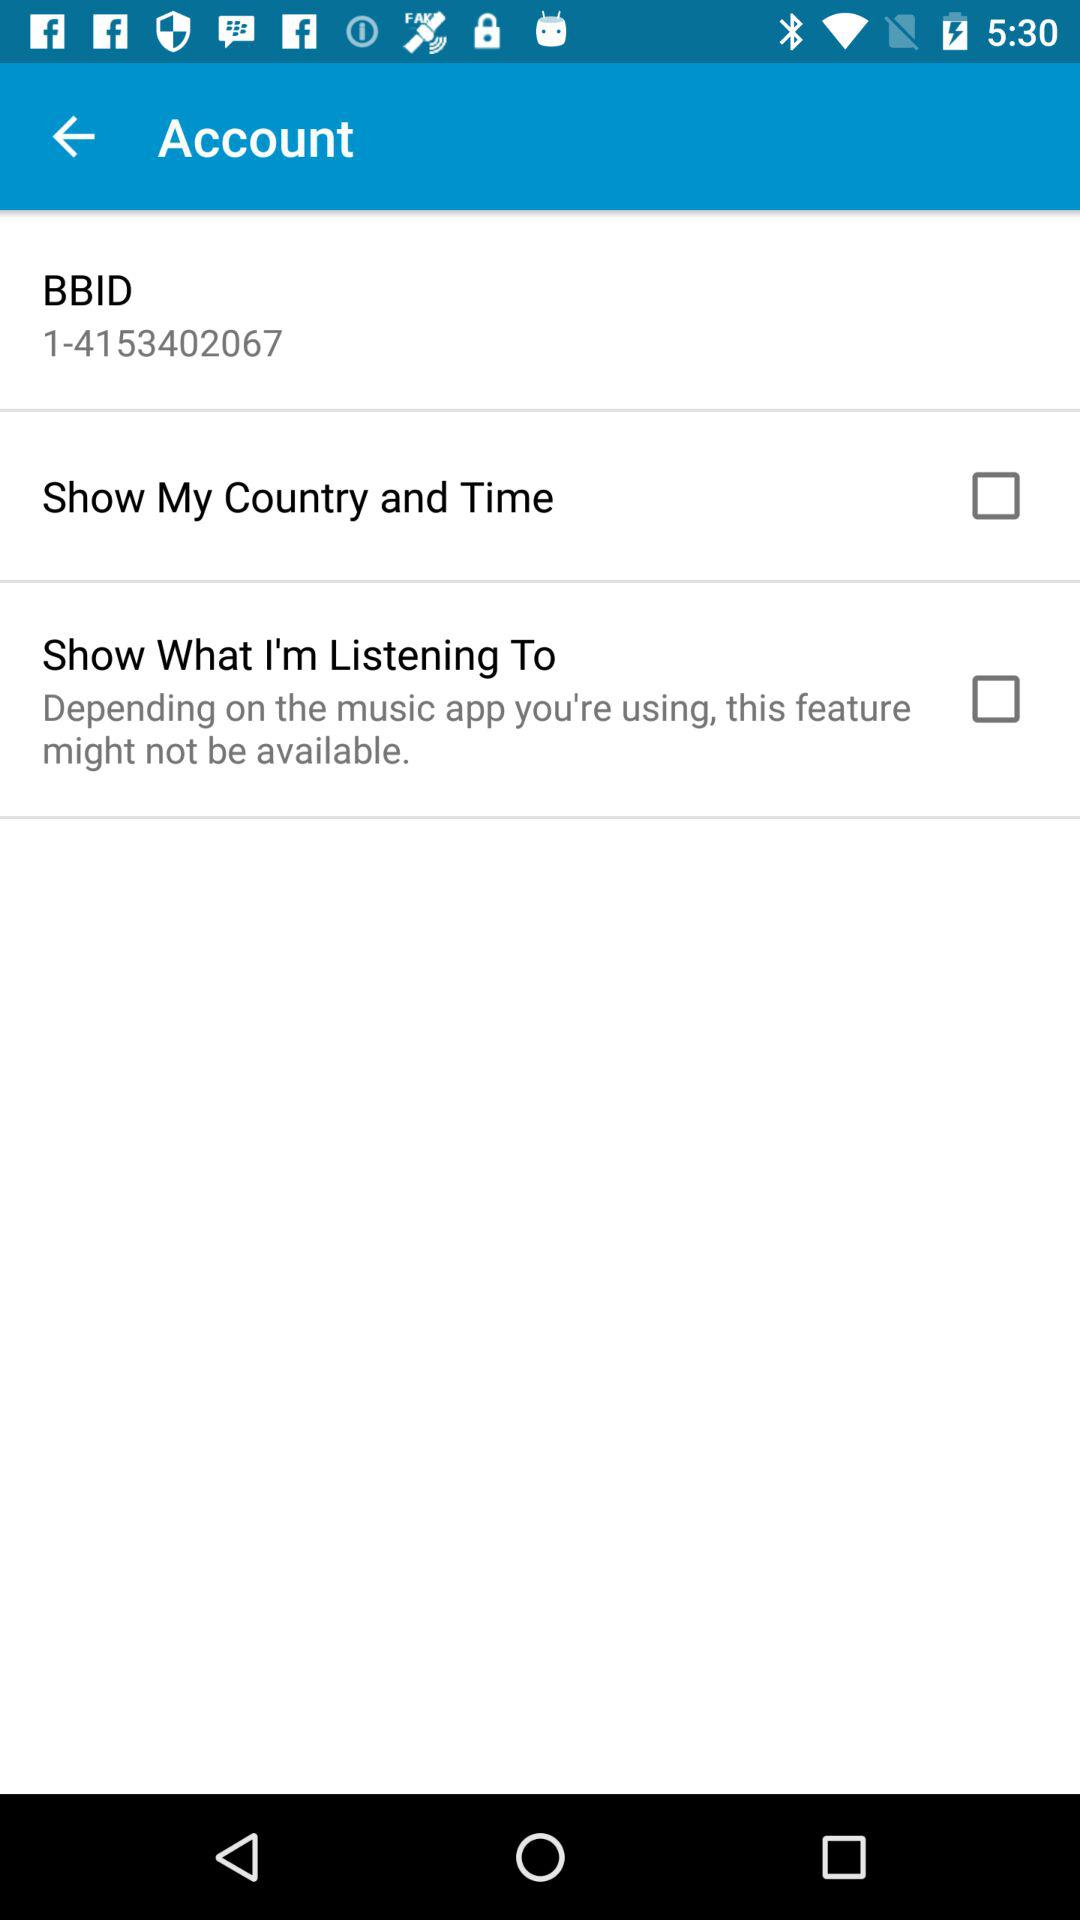What is the status of "Show My Country and Time"? The status of "Show My Country and Time" is "off". 